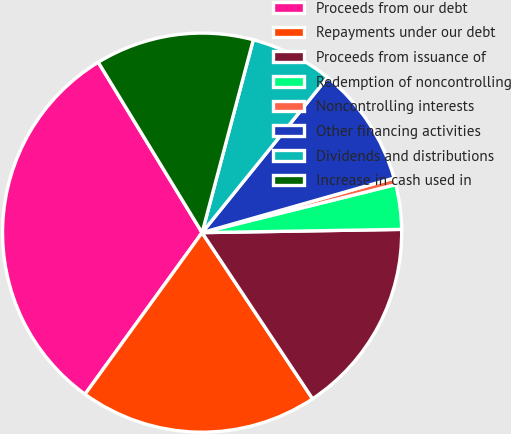Convert chart to OTSL. <chart><loc_0><loc_0><loc_500><loc_500><pie_chart><fcel>Proceeds from our debt<fcel>Repayments under our debt<fcel>Proceeds from issuance of<fcel>Redemption of noncontrolling<fcel>Noncontrolling interests<fcel>Other financing activities<fcel>Dividends and distributions<fcel>Increase in cash used in<nl><fcel>31.31%<fcel>19.32%<fcel>15.92%<fcel>3.61%<fcel>0.54%<fcel>9.77%<fcel>6.69%<fcel>12.84%<nl></chart> 